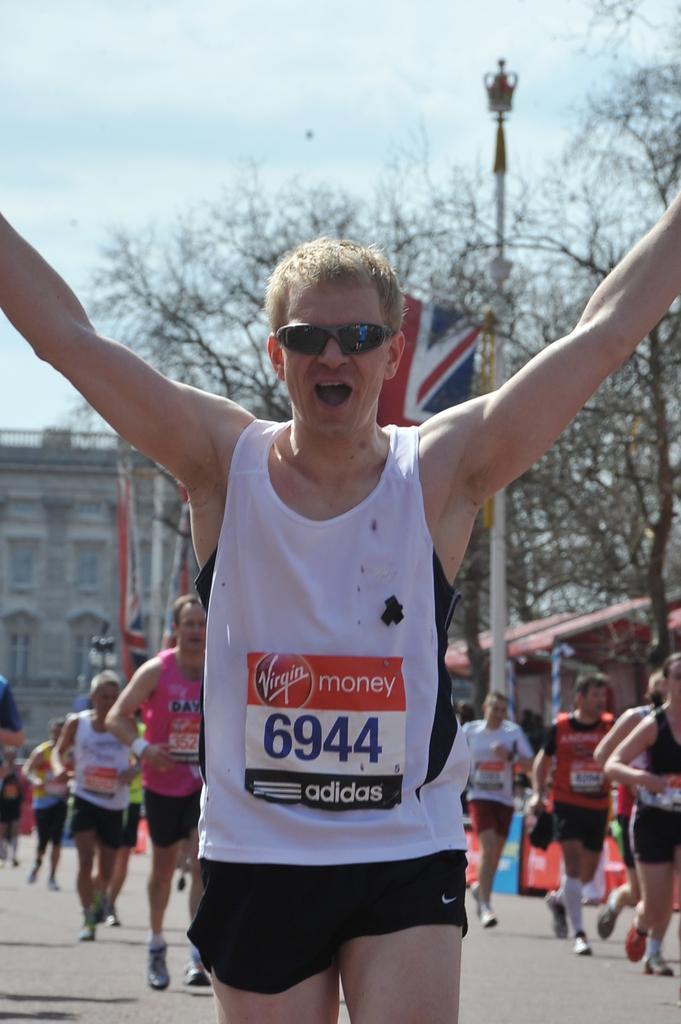Could you give a brief overview of what you see in this image? In this image in the foreground there is one person who is running and he is wearing goggles, and in the background there are a group of people running and there are some boards, poles, flags, light, trees and the building. At the bottom of the there is road and at the top there is sky. 